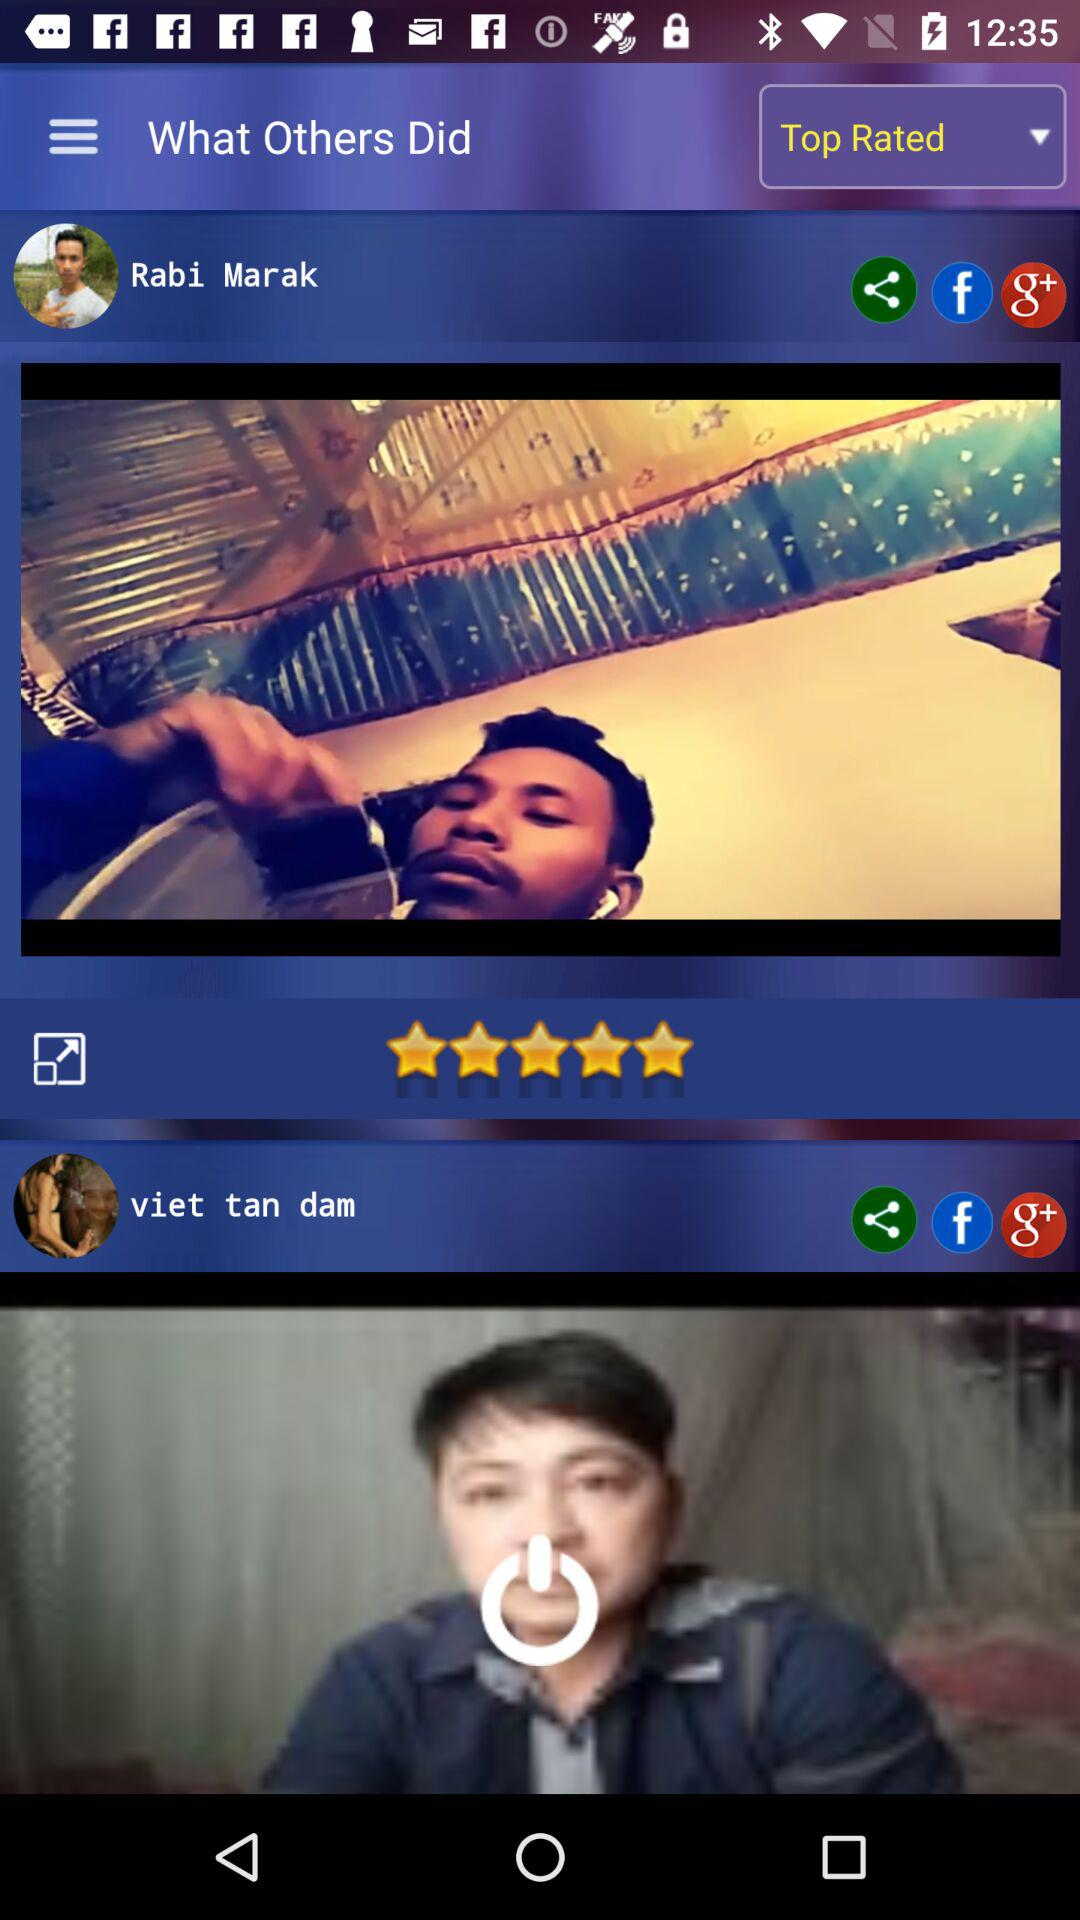When was the post by Rabi Marak posted?
When the provided information is insufficient, respond with <no answer>. <no answer> 